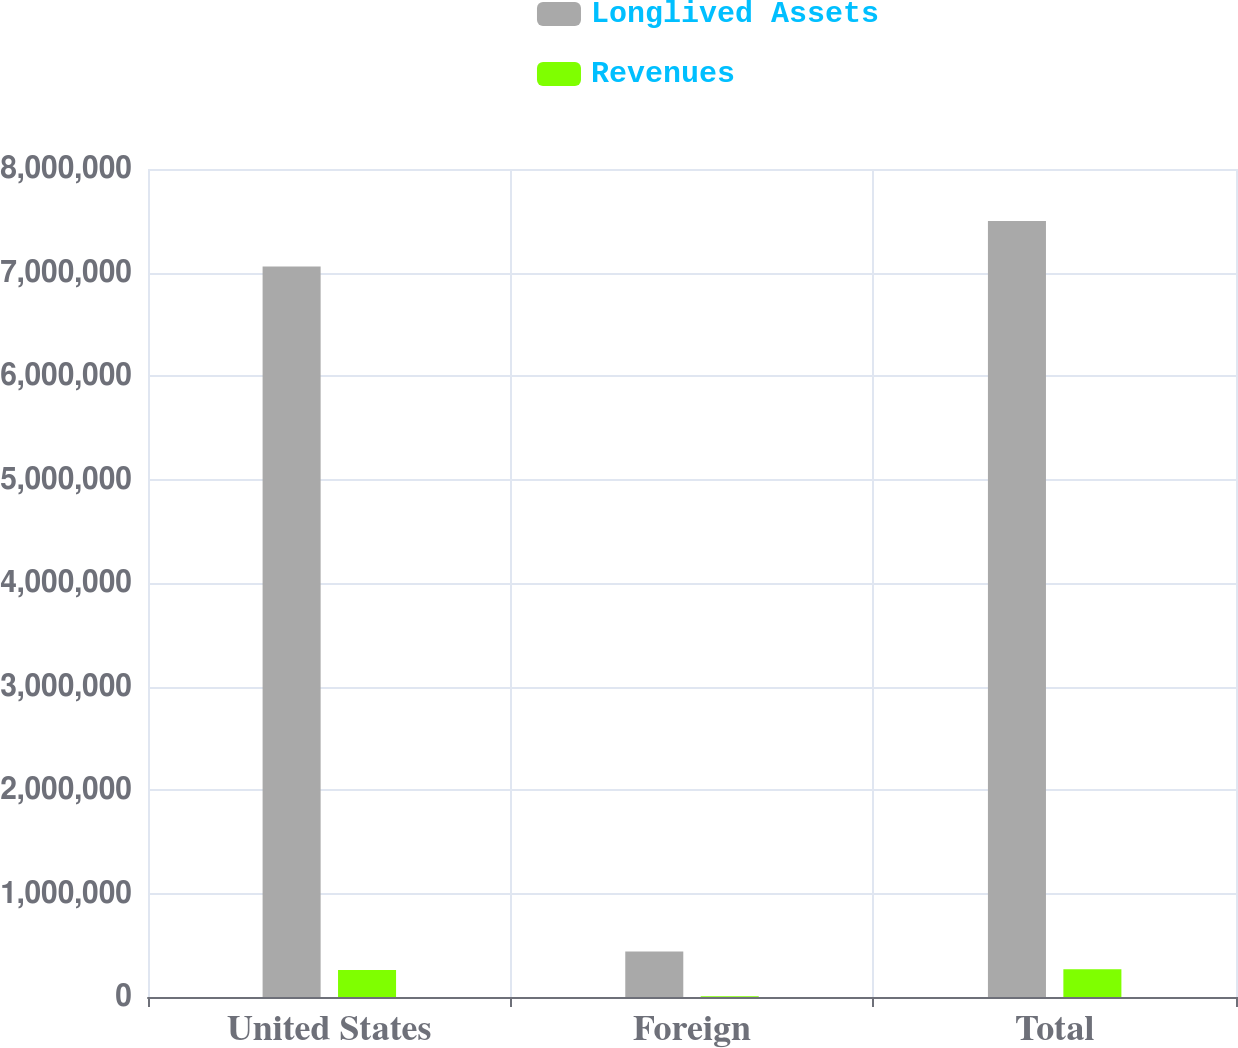Convert chart to OTSL. <chart><loc_0><loc_0><loc_500><loc_500><stacked_bar_chart><ecel><fcel>United States<fcel>Foreign<fcel>Total<nl><fcel>Longlived Assets<fcel>7.05719e+06<fcel>440488<fcel>7.49768e+06<nl><fcel>Revenues<fcel>260792<fcel>6928<fcel>267720<nl></chart> 